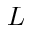Convert formula to latex. <formula><loc_0><loc_0><loc_500><loc_500>L \,</formula> 